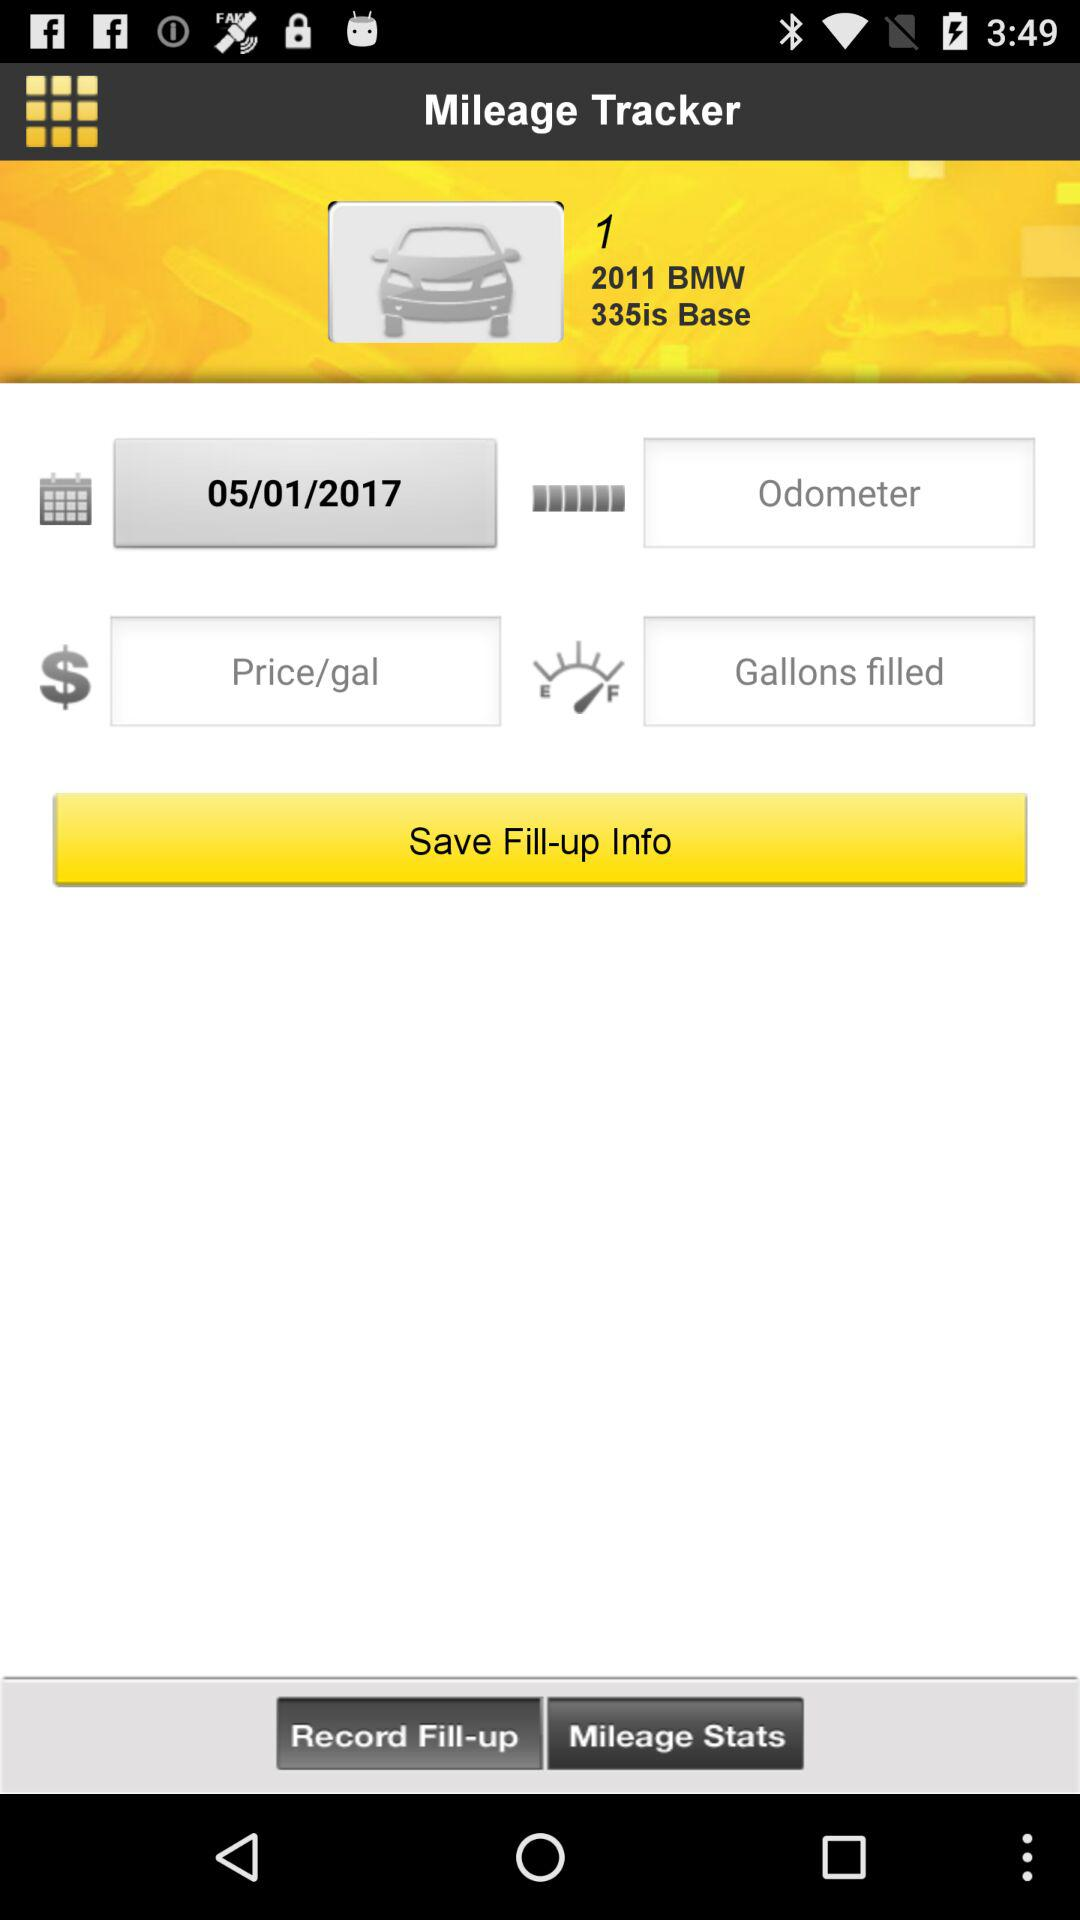Which model year is this? The year is 2011. 